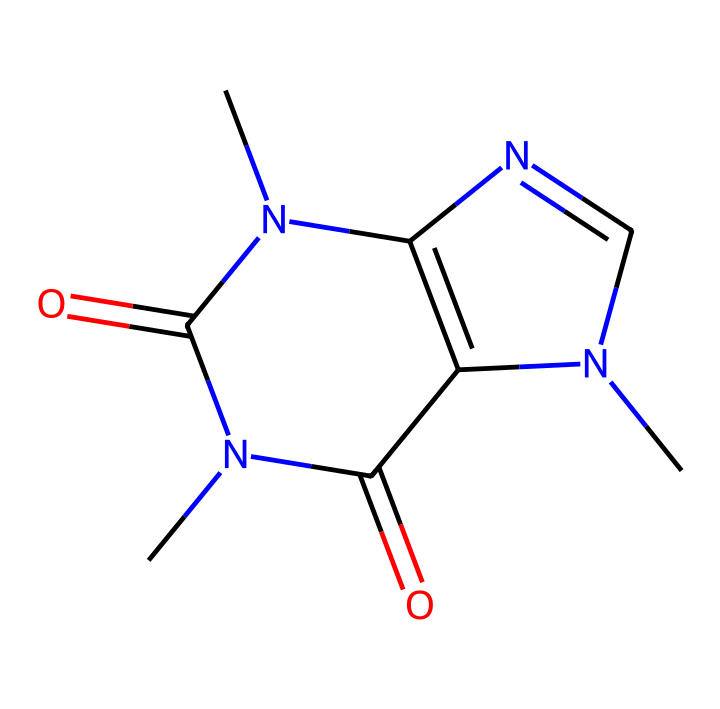What is the name of this chemical? The given SMILES notation corresponds to caffeine, a central nervous system stimulant commonly found in coffee.
Answer: caffeine How many nitrogen atoms are in the structure? Analyzing the SMILES representation, there are four nitrogen atoms represented by "N", which can be counted directly from the notation.
Answer: four What type of compound is caffeine classified as? Caffeine is classified as an alkaloid, which is a naturally occurring compound that primarily contains basic nitrogen atoms. This classification stems from its structure, which includes nitrogen atoms in its rings.
Answer: alkaloid What is the total number of carbon atoms in this chemical? Counting the carbon atoms from the SMILES, we find a total of eight carbon atoms marked as "C".
Answer: eight How many double bonds are present in the chemical structure? Observing the SMILES, two instances of "=" indicate double bonds: one between two carbon atoms and another between a carbon and a nitrogen. Thus, there are two double bonds in the structure.
Answer: two Which functional groups are present in the caffeine structure? The caffeine structure features the following functional groups: amide groups (indicated by "C(=O)N") and dimethylamino group (seen in "N(C)"). Both reflect the properties of caffeine as an alkaloid.
Answer: amide, dimethylamino What is the molecular formula based on the structure? By counting the atoms represented in the SMILES: C (8), H (10), N (4), and O (2), we can derive the molecular formula as C8H10N4O2.
Answer: C8H10N4O2 